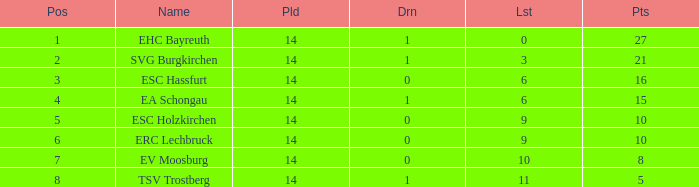What's the most points for Ea Schongau with more than 1 drawn? None. 